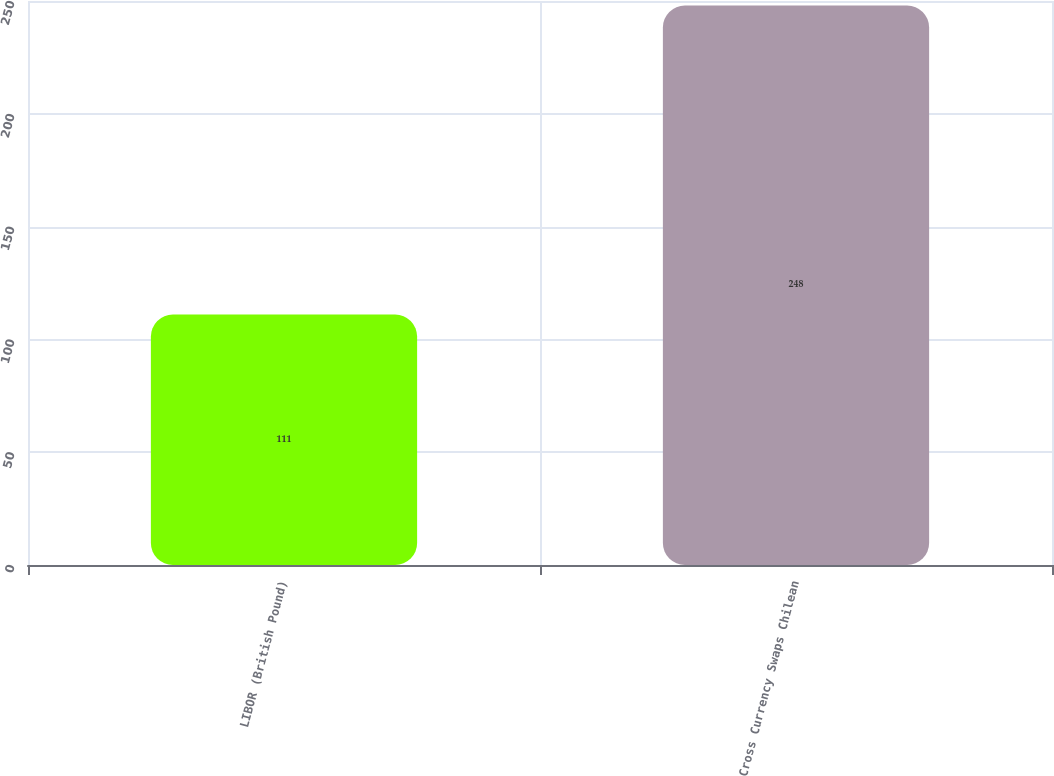<chart> <loc_0><loc_0><loc_500><loc_500><bar_chart><fcel>LIBOR (British Pound)<fcel>Cross Currency Swaps Chilean<nl><fcel>111<fcel>248<nl></chart> 